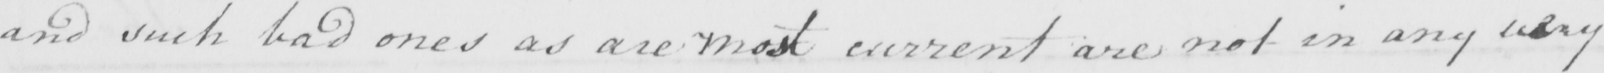Please provide the text content of this handwritten line. and such bad ones as are most current are not in any way 